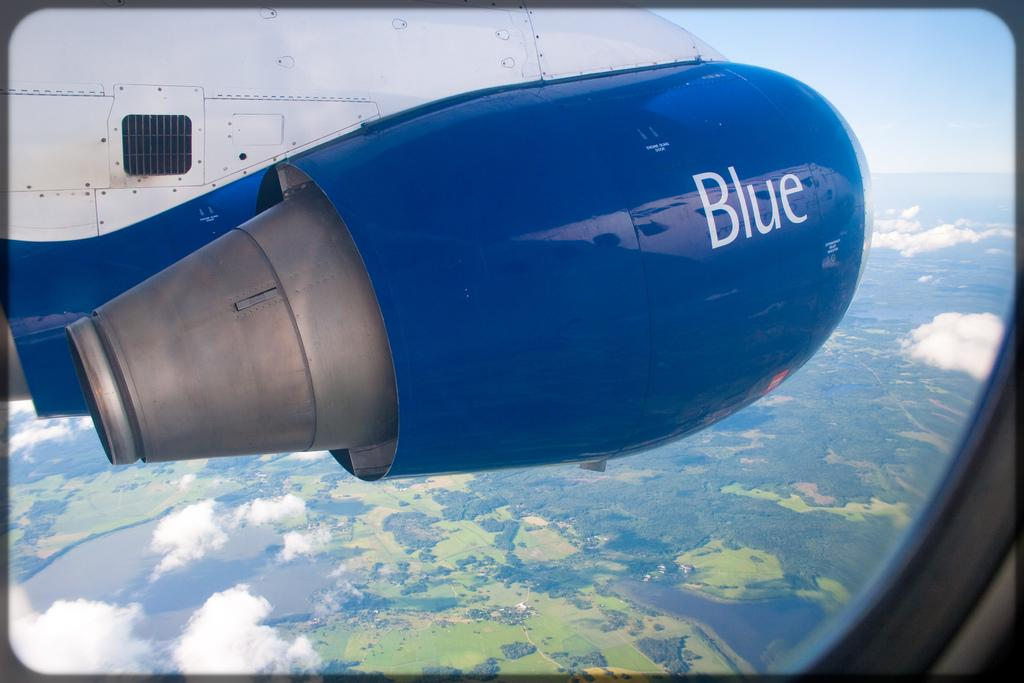Provide a one-sentence caption for the provided image. a jet engine with the word BLUE outside an airplane window. 